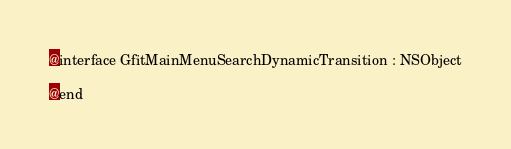Convert code to text. <code><loc_0><loc_0><loc_500><loc_500><_C_>
@interface GfitMainMenuSearchDynamicTransition : NSObject

@end
</code> 